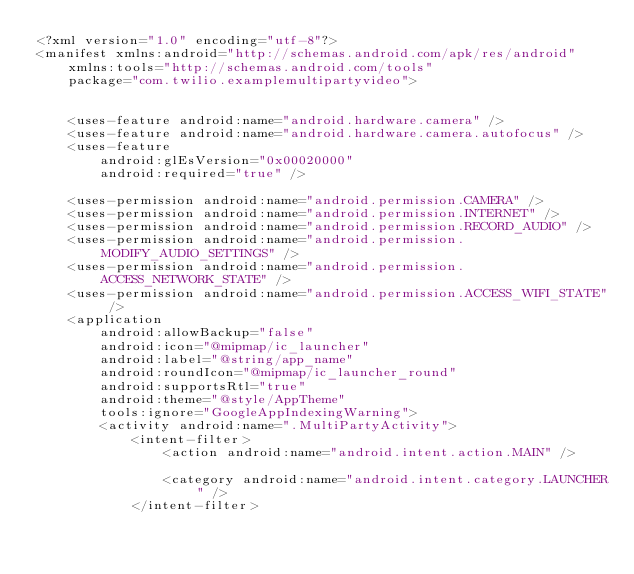Convert code to text. <code><loc_0><loc_0><loc_500><loc_500><_XML_><?xml version="1.0" encoding="utf-8"?>
<manifest xmlns:android="http://schemas.android.com/apk/res/android"
    xmlns:tools="http://schemas.android.com/tools"
    package="com.twilio.examplemultipartyvideo">


    <uses-feature android:name="android.hardware.camera" />
    <uses-feature android:name="android.hardware.camera.autofocus" />
    <uses-feature
        android:glEsVersion="0x00020000"
        android:required="true" />

    <uses-permission android:name="android.permission.CAMERA" />
    <uses-permission android:name="android.permission.INTERNET" />
    <uses-permission android:name="android.permission.RECORD_AUDIO" />
    <uses-permission android:name="android.permission.MODIFY_AUDIO_SETTINGS" />
    <uses-permission android:name="android.permission.ACCESS_NETWORK_STATE" />
    <uses-permission android:name="android.permission.ACCESS_WIFI_STATE" />
    <application
        android:allowBackup="false"
        android:icon="@mipmap/ic_launcher"
        android:label="@string/app_name"
        android:roundIcon="@mipmap/ic_launcher_round"
        android:supportsRtl="true"
        android:theme="@style/AppTheme"
        tools:ignore="GoogleAppIndexingWarning">
        <activity android:name=".MultiPartyActivity">
            <intent-filter>
                <action android:name="android.intent.action.MAIN" />

                <category android:name="android.intent.category.LAUNCHER" />
            </intent-filter></code> 